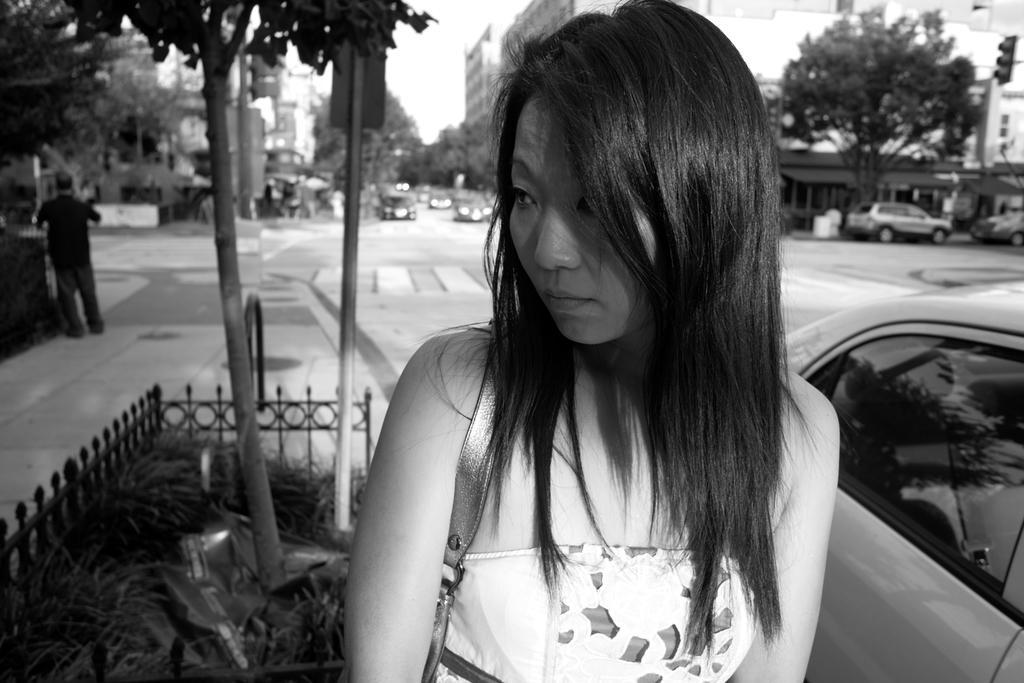What type of natural elements can be seen in the image? There are trees in the image. What type of man-made structures are present in the image? There are buildings in the image. What type of transportation can be seen in the image? There are vehicles in the image. Can you describe the woman in the image? The woman is standing in the front of the image and is wearing a white dress. What is visible at the top of the image? The sky is visible at the top of the image. How many socks are visible on the woman's feet in the image? There is no information about socks in the image, as the woman is wearing a dress and her feet are not visible. Can you describe the skateboarding skills of the woman in the image? There is no information about skateboarding in the image, as there are no skateboards or related activities depicted. 